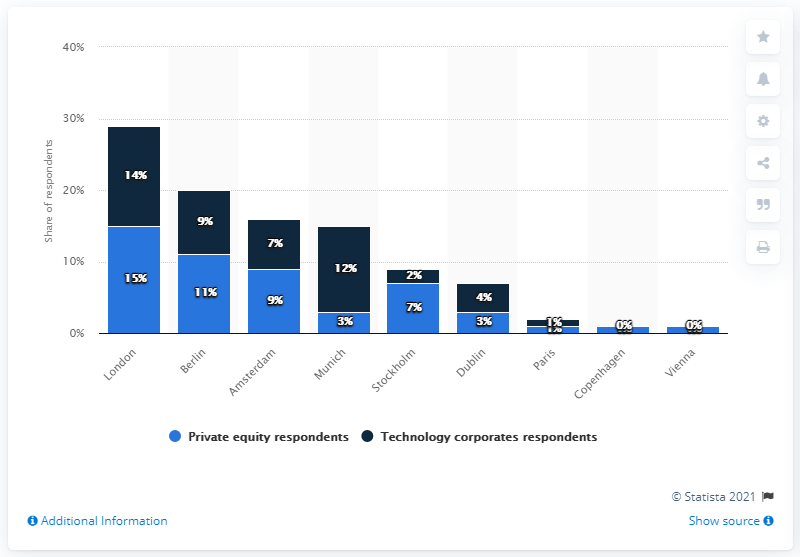Point out several critical features in this image. London was cited as the leading European technology start-up destination. 